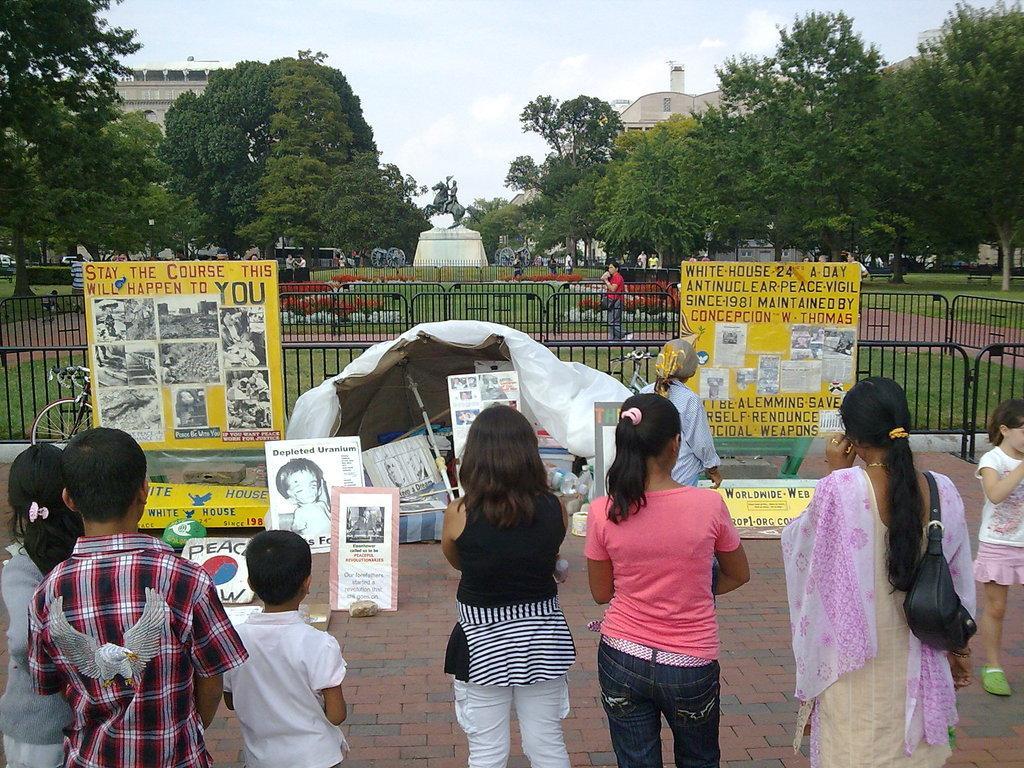In one or two sentences, can you explain what this image depicts? In this image we can see few people standing on the pavement, there are few boards with text and images and there is a tent, a bicycle, fence, there are few trees, a statue, buildings and the sky in the background. 